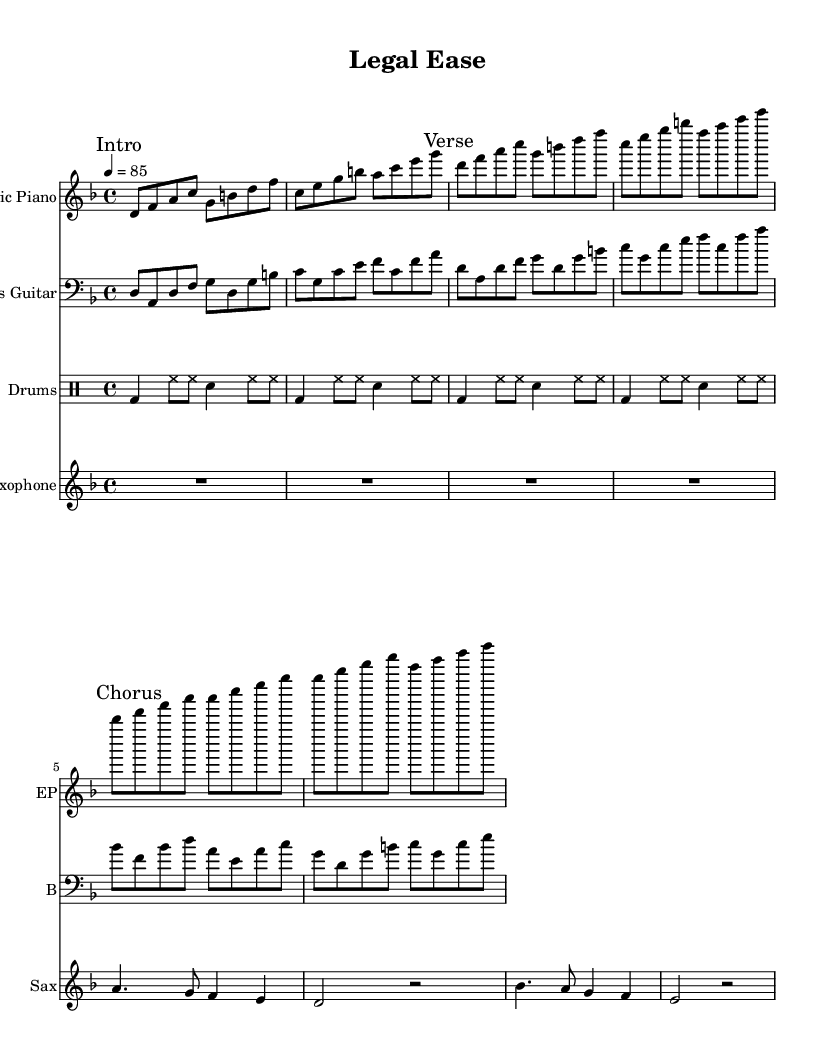What is the key signature of this music? The key signature is D minor, which has one flat (B flat). This is indicated before the beginning of the staff, showing that D is the root note, making it the tonal center.
Answer: D minor What is the time signature of the piece? The time signature is 4/4, which means there are four beats in each measure and the quarter note gets one beat. This is indicated next to the key signature at the start of the staff.
Answer: 4/4 What is the tempo marking for this music? The tempo marking is 85 BPM, which indicates that the piece should be played at a moderate pace of 85 beats per minute. This is shown at the beginning of the score and sets the mood for a laid-back funk vibe.
Answer: 85 Which instrument has the highest written pitch in this score? The instrument with the highest written pitch is the Saxophone. By analyzing the notes, we see that the highest note in the saxophone part is A, while the electric piano and bass guitar do not exceed this pitch.
Answer: Saxophone How many measures are in the verse section of the music? The verse section consists of two measures, which can be counted as the distinct musical phrases that repeat. This can be identified after checking the structure labeled "Verse" in the sheet music.
Answer: 2 What type of drum beats are primarily used in this piece? The primary drum beats used in this piece are bass drum and hi-hat patterns. This is evident from the repetition of specific patterns throughout the drum part, emphasizing the funk rhythm.
Answer: Bass and hi-hat Which chord progression dominates the chorus section? The chord progression that dominates the chorus is the transition between B flat, D, F, A, and G, reflecting typical funk harmonies that provide a smooth yet engaging musical discourse. This can be deduced from the notes found in the "Chorus" section.
Answer: B flat, D, F, A, G 